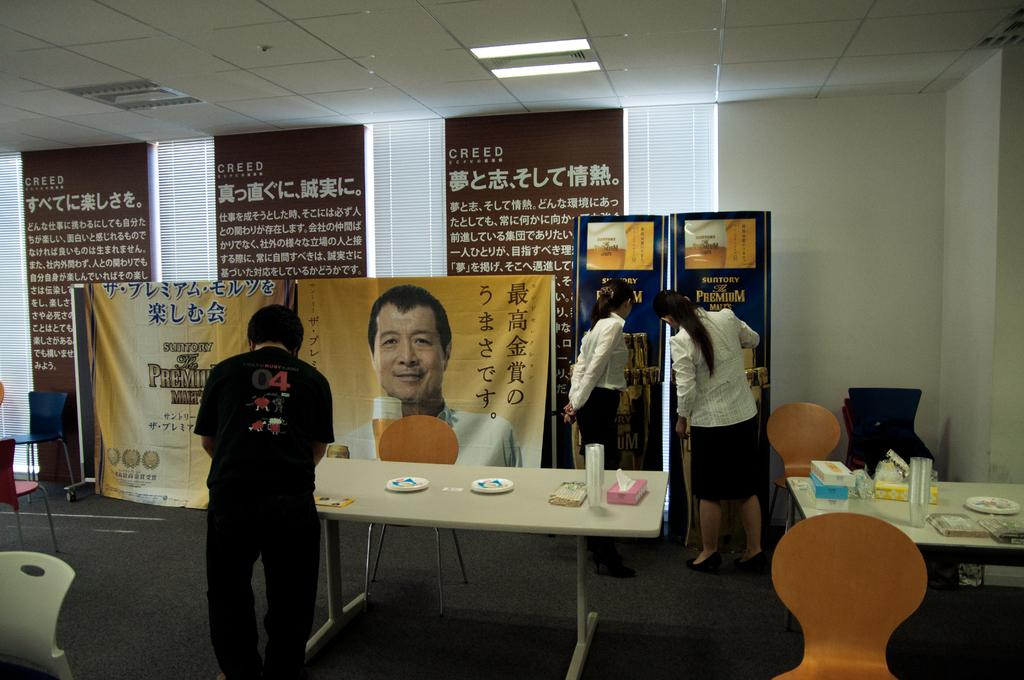How many people are in the image? There are two women and a man in the image. What are the people in the image doing? The people are standing. What objects can be seen on the table in the image? There are plates and glasses on the table. What additional item is visible in the image? There is a banner visible in the image. What type of furniture is present in the image? There are chairs in the image. Is there a veil covering any of the plates on the table? There is no veil present in the image, and none of the plates are covered. How many apples are on the table in the image? There are no apples visible in the image. 